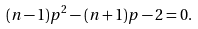<formula> <loc_0><loc_0><loc_500><loc_500>( n - 1 ) p ^ { 2 } - ( n + 1 ) p - 2 = 0 .</formula> 